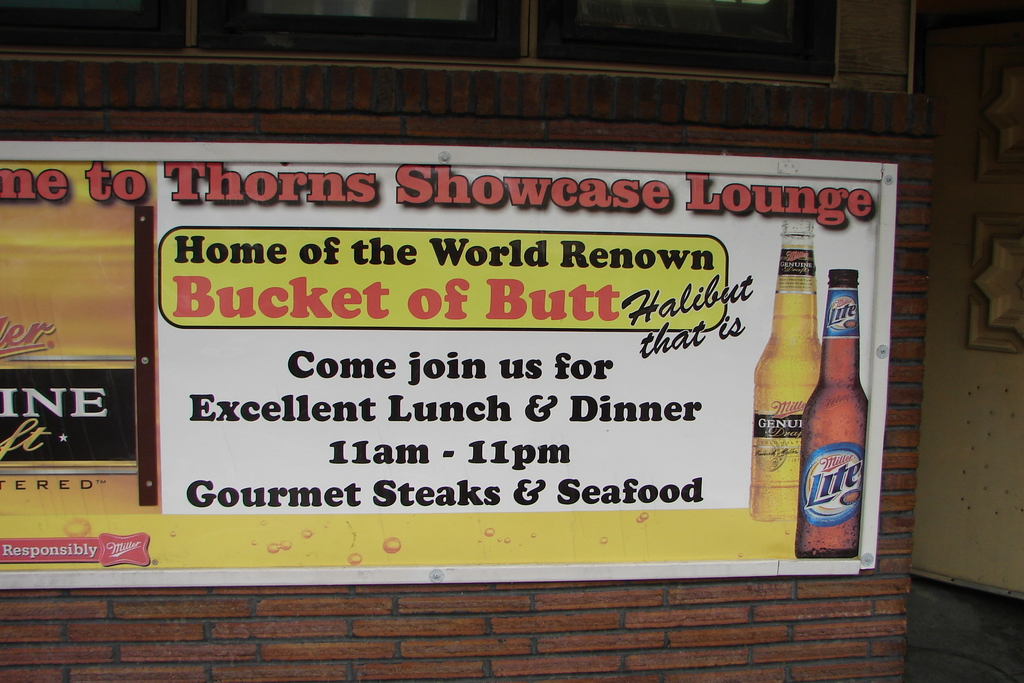What is this photo about'?
 The image showcases a vibrant sign for the Thorns Showcase Lounge, a popular dining spot renowned for its "Bucket of Butt Halibut". The sign invites patrons to join them for an excellent lunch and dinner, served from 11am to 11pm. In addition to their signature halibut dish, the lounge also prides itself on offering gourmet steaks and seafood. A Miller Lite beer bottle is playfully positioned on the right side of the sign, hinting at the variety of beverages available to complement their meals. 